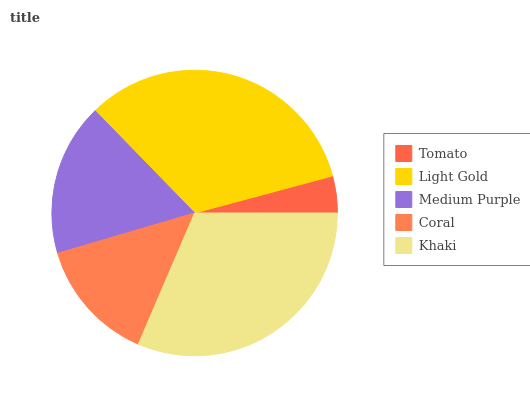Is Tomato the minimum?
Answer yes or no. Yes. Is Light Gold the maximum?
Answer yes or no. Yes. Is Medium Purple the minimum?
Answer yes or no. No. Is Medium Purple the maximum?
Answer yes or no. No. Is Light Gold greater than Medium Purple?
Answer yes or no. Yes. Is Medium Purple less than Light Gold?
Answer yes or no. Yes. Is Medium Purple greater than Light Gold?
Answer yes or no. No. Is Light Gold less than Medium Purple?
Answer yes or no. No. Is Medium Purple the high median?
Answer yes or no. Yes. Is Medium Purple the low median?
Answer yes or no. Yes. Is Tomato the high median?
Answer yes or no. No. Is Khaki the low median?
Answer yes or no. No. 